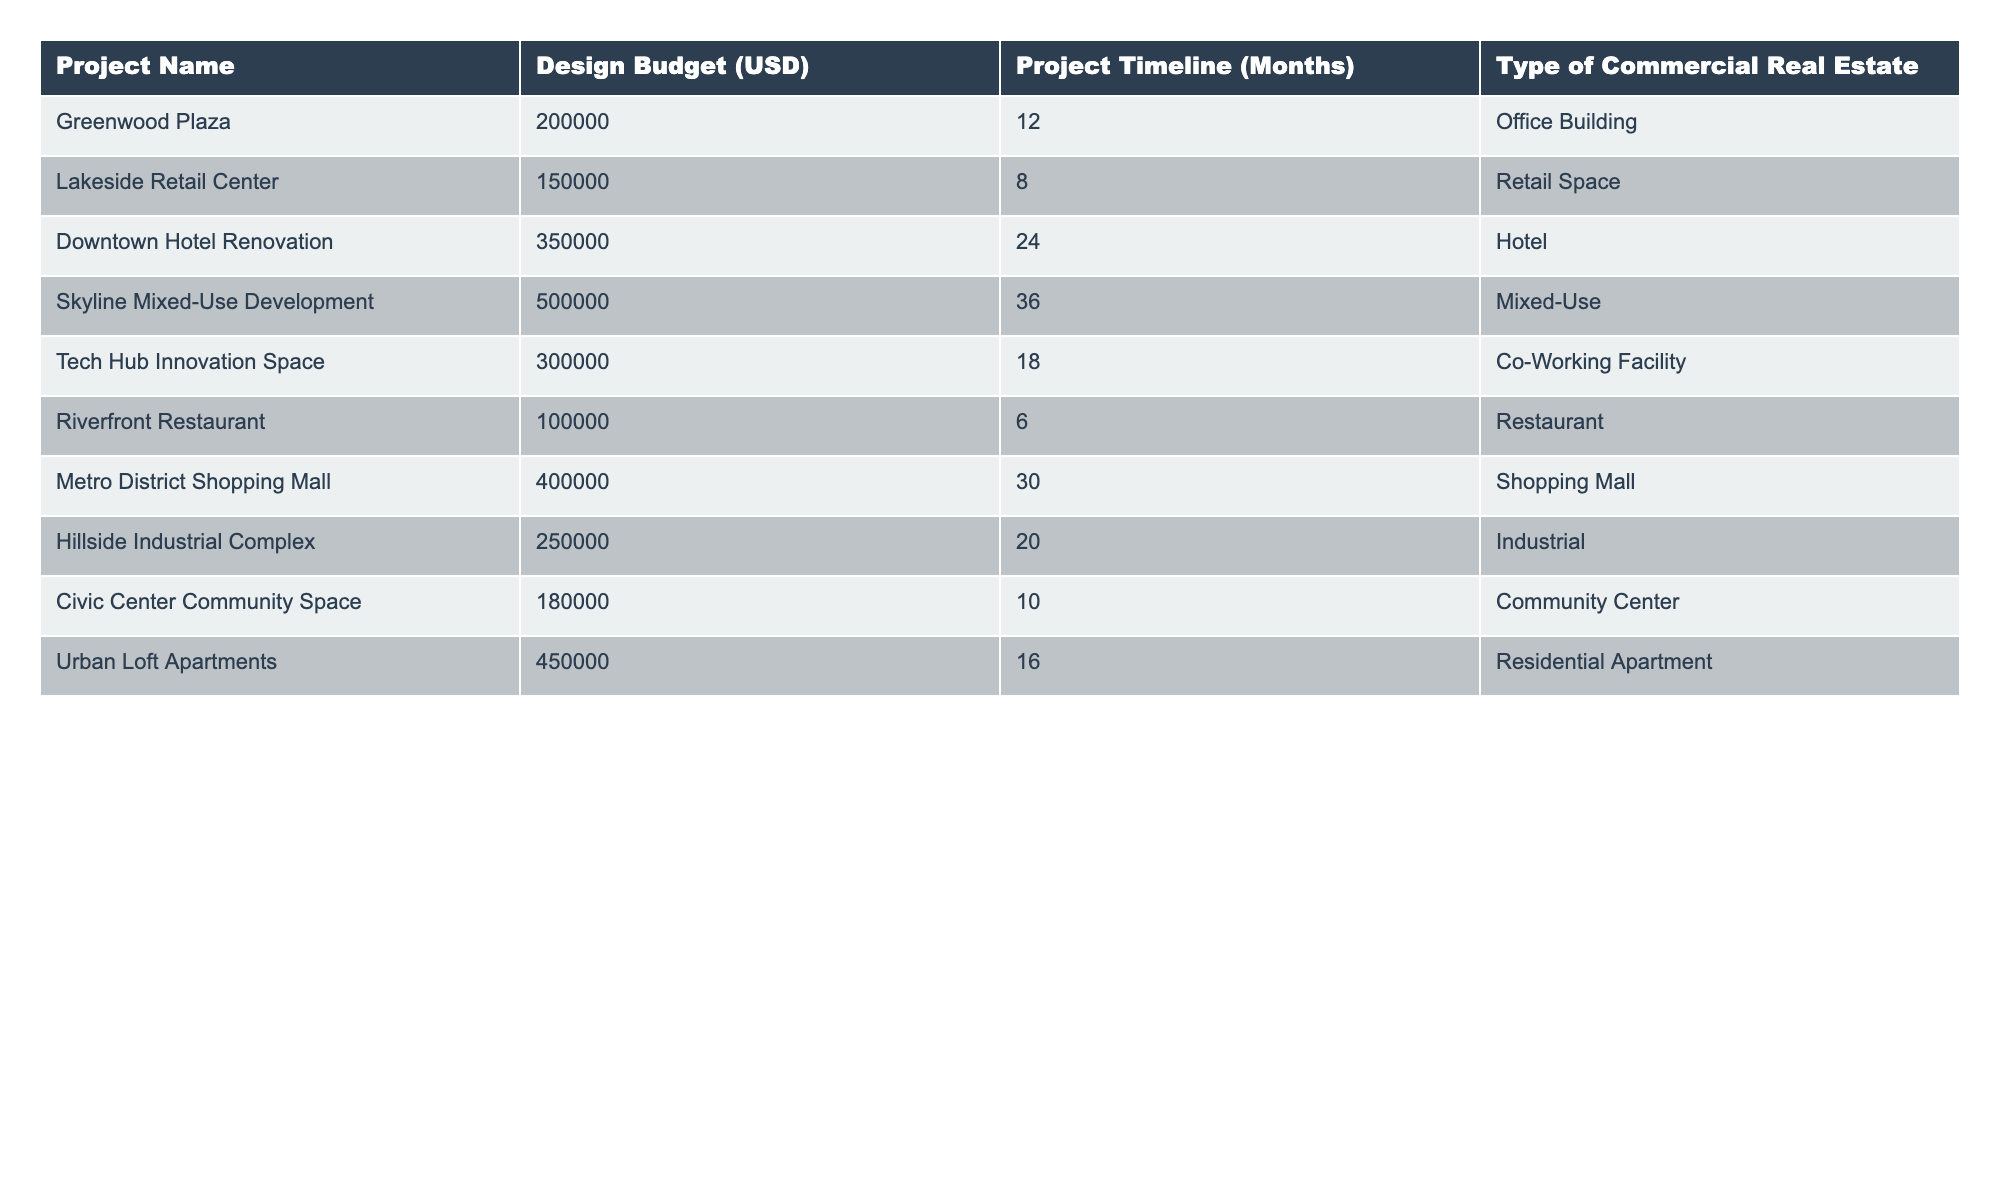What is the design budget for the Downtown Hotel Renovation project? The table specifies that the design budget for the Downtown Hotel Renovation project is listed in the "Design Budget (USD)" column next to the project name. The value is 350,000.
Answer: 350000 How long is the project timeline for the Riverfront Restaurant? By checking the "Project Timeline (Months)" column corresponding to the Riverfront Restaurant, we find that the timeline is 6 months.
Answer: 6 months Which project has the highest design budget? We assess the "Design Budget (USD)" column for each project, identifying the maximum value. The Skyline Mixed-Use Development has the highest budget at 500,000.
Answer: 500000 What is the average design budget for all projects listed? To calculate the average, sum the design budgets of all projects: 200,000 + 150,000 + 350,000 + 500,000 + 300,000 + 100,000 + 400,000 + 250,000 + 180,000 + 450,000 = 2,780,000. There are 10 projects, so the average is 2,780,000 / 10 = 278,000.
Answer: 278000 Is there any project that has a budget exceeding 400,000? We review the "Design Budget (USD)" column for values over 400,000. The projects that exceed this amount are Skyline Mixed-Use Development (500,000) and Downtown Hotel Renovation (350,000). Thus, yes, there is at least one project that exceeds 400,000.
Answer: Yes What is the difference between the project timelines for the longest and shortest projects? The longest project is the Skyline Mixed-Use Development with a timeline of 36 months, and the shortest project is the Riverfront Restaurant with a timeline of 6 months. The difference is 36 - 6 = 30 months.
Answer: 30 months Which type of commercial real estate has the lowest budget? We inspect the "Design Budget (USD)" column to find the lowest budget. The Riverfront Restaurant has the lowest budget of 100,000 among all types of commercial real estate.
Answer: Restaurant How many projects have a timeline greater than 20 months? From the "Project Timeline (Months)" column, we count the projects with timelines greater than 20 months. They are: Downtown Hotel Renovation (24 months), Skyline Mixed-Use Development (36 months), and Metro District Shopping Mall (30 months). Thus, there are 3 projects.
Answer: 3 Are there any projects related to residential real estate listed? Looking through the "Type of Commercial Real Estate" column, we identify that "Urban Loft Apartments" is categorized as a Residential Apartment, making the answer yes.
Answer: Yes What is the total design budget for Office Buildings in the table? We filter the "Design Budget (USD)" for projects identified as Office Buildings, which is only Greenwood Plaza with a budget of 200,000. Therefore, the total design budget for Office Buildings is 200,000.
Answer: 200000 